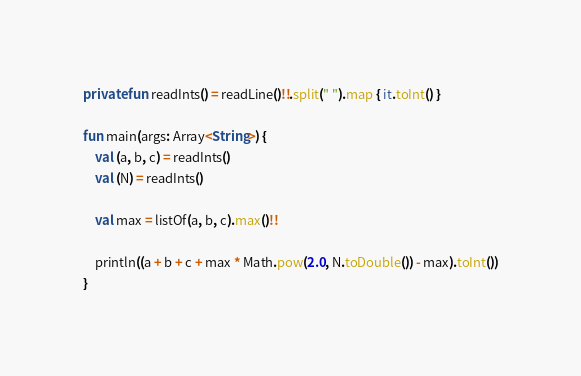Convert code to text. <code><loc_0><loc_0><loc_500><loc_500><_Kotlin_>private fun readInts() = readLine()!!.split(" ").map { it.toInt() }

fun main(args: Array<String>) {
    val (a, b, c) = readInts()
    val (N) = readInts()

    val max = listOf(a, b, c).max()!!

    println((a + b + c + max * Math.pow(2.0, N.toDouble()) - max).toInt())
}</code> 